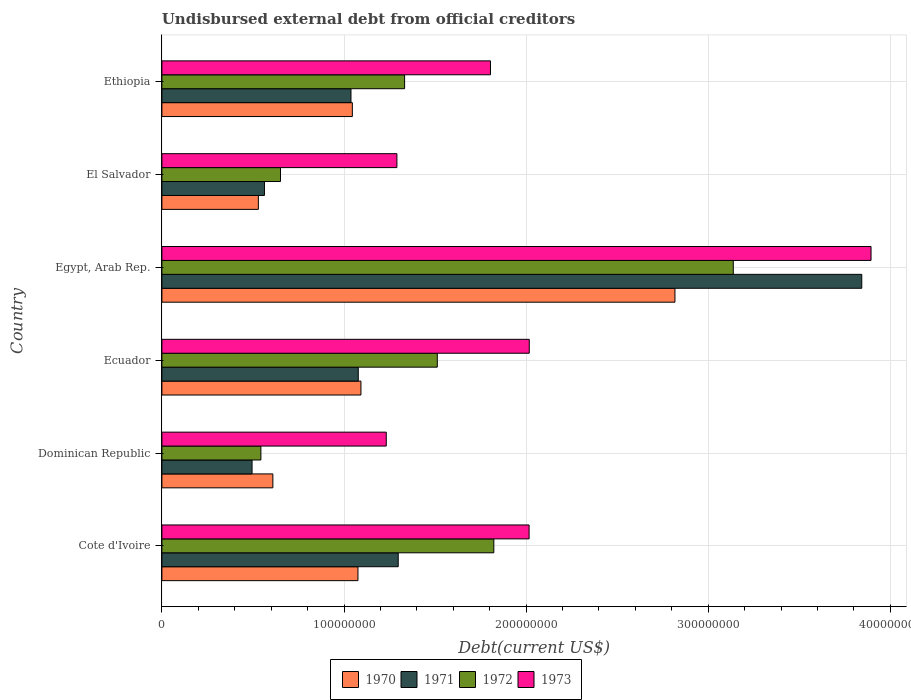How many different coloured bars are there?
Provide a short and direct response. 4. Are the number of bars per tick equal to the number of legend labels?
Keep it short and to the point. Yes. Are the number of bars on each tick of the Y-axis equal?
Give a very brief answer. Yes. How many bars are there on the 4th tick from the top?
Your answer should be very brief. 4. What is the label of the 3rd group of bars from the top?
Make the answer very short. Egypt, Arab Rep. In how many cases, is the number of bars for a given country not equal to the number of legend labels?
Your response must be concise. 0. What is the total debt in 1972 in Egypt, Arab Rep.?
Give a very brief answer. 3.14e+08. Across all countries, what is the maximum total debt in 1972?
Give a very brief answer. 3.14e+08. Across all countries, what is the minimum total debt in 1970?
Offer a very short reply. 5.30e+07. In which country was the total debt in 1971 maximum?
Offer a very short reply. Egypt, Arab Rep. In which country was the total debt in 1970 minimum?
Offer a terse response. El Salvador. What is the total total debt in 1972 in the graph?
Your response must be concise. 9.00e+08. What is the difference between the total debt in 1973 in Egypt, Arab Rep. and that in El Salvador?
Provide a succinct answer. 2.60e+08. What is the difference between the total debt in 1972 in Cote d'Ivoire and the total debt in 1971 in El Salvador?
Provide a succinct answer. 1.26e+08. What is the average total debt in 1971 per country?
Keep it short and to the point. 1.39e+08. What is the difference between the total debt in 1973 and total debt in 1970 in Egypt, Arab Rep.?
Your answer should be compact. 1.08e+08. In how many countries, is the total debt in 1972 greater than 220000000 US$?
Make the answer very short. 1. What is the ratio of the total debt in 1971 in Ecuador to that in Ethiopia?
Offer a very short reply. 1.04. Is the total debt in 1972 in Ecuador less than that in Ethiopia?
Offer a very short reply. No. What is the difference between the highest and the second highest total debt in 1972?
Your answer should be very brief. 1.31e+08. What is the difference between the highest and the lowest total debt in 1972?
Provide a short and direct response. 2.59e+08. Is it the case that in every country, the sum of the total debt in 1970 and total debt in 1973 is greater than the sum of total debt in 1972 and total debt in 1971?
Provide a short and direct response. No. What does the 2nd bar from the top in Ethiopia represents?
Offer a very short reply. 1972. How many bars are there?
Ensure brevity in your answer.  24. What is the difference between two consecutive major ticks on the X-axis?
Offer a terse response. 1.00e+08. Does the graph contain grids?
Give a very brief answer. Yes. How many legend labels are there?
Your response must be concise. 4. What is the title of the graph?
Ensure brevity in your answer.  Undisbursed external debt from official creditors. What is the label or title of the X-axis?
Your answer should be very brief. Debt(current US$). What is the label or title of the Y-axis?
Provide a succinct answer. Country. What is the Debt(current US$) in 1970 in Cote d'Ivoire?
Offer a very short reply. 1.08e+08. What is the Debt(current US$) of 1971 in Cote d'Ivoire?
Ensure brevity in your answer.  1.30e+08. What is the Debt(current US$) of 1972 in Cote d'Ivoire?
Your answer should be compact. 1.82e+08. What is the Debt(current US$) of 1973 in Cote d'Ivoire?
Offer a very short reply. 2.02e+08. What is the Debt(current US$) of 1970 in Dominican Republic?
Your answer should be compact. 6.09e+07. What is the Debt(current US$) of 1971 in Dominican Republic?
Give a very brief answer. 4.95e+07. What is the Debt(current US$) in 1972 in Dominican Republic?
Offer a very short reply. 5.44e+07. What is the Debt(current US$) of 1973 in Dominican Republic?
Offer a terse response. 1.23e+08. What is the Debt(current US$) in 1970 in Ecuador?
Your answer should be compact. 1.09e+08. What is the Debt(current US$) in 1971 in Ecuador?
Provide a short and direct response. 1.08e+08. What is the Debt(current US$) in 1972 in Ecuador?
Offer a very short reply. 1.51e+08. What is the Debt(current US$) in 1973 in Ecuador?
Your answer should be compact. 2.02e+08. What is the Debt(current US$) in 1970 in Egypt, Arab Rep.?
Keep it short and to the point. 2.82e+08. What is the Debt(current US$) in 1971 in Egypt, Arab Rep.?
Your answer should be compact. 3.84e+08. What is the Debt(current US$) of 1972 in Egypt, Arab Rep.?
Offer a terse response. 3.14e+08. What is the Debt(current US$) in 1973 in Egypt, Arab Rep.?
Give a very brief answer. 3.89e+08. What is the Debt(current US$) of 1970 in El Salvador?
Ensure brevity in your answer.  5.30e+07. What is the Debt(current US$) of 1971 in El Salvador?
Provide a short and direct response. 5.63e+07. What is the Debt(current US$) of 1972 in El Salvador?
Give a very brief answer. 6.51e+07. What is the Debt(current US$) in 1973 in El Salvador?
Ensure brevity in your answer.  1.29e+08. What is the Debt(current US$) in 1970 in Ethiopia?
Your answer should be compact. 1.05e+08. What is the Debt(current US$) of 1971 in Ethiopia?
Keep it short and to the point. 1.04e+08. What is the Debt(current US$) of 1972 in Ethiopia?
Your answer should be compact. 1.33e+08. What is the Debt(current US$) in 1973 in Ethiopia?
Provide a short and direct response. 1.80e+08. Across all countries, what is the maximum Debt(current US$) of 1970?
Offer a very short reply. 2.82e+08. Across all countries, what is the maximum Debt(current US$) in 1971?
Offer a very short reply. 3.84e+08. Across all countries, what is the maximum Debt(current US$) of 1972?
Your answer should be very brief. 3.14e+08. Across all countries, what is the maximum Debt(current US$) in 1973?
Your answer should be compact. 3.89e+08. Across all countries, what is the minimum Debt(current US$) in 1970?
Keep it short and to the point. 5.30e+07. Across all countries, what is the minimum Debt(current US$) in 1971?
Offer a very short reply. 4.95e+07. Across all countries, what is the minimum Debt(current US$) in 1972?
Offer a terse response. 5.44e+07. Across all countries, what is the minimum Debt(current US$) of 1973?
Ensure brevity in your answer.  1.23e+08. What is the total Debt(current US$) of 1970 in the graph?
Give a very brief answer. 7.17e+08. What is the total Debt(current US$) in 1971 in the graph?
Make the answer very short. 8.32e+08. What is the total Debt(current US$) of 1972 in the graph?
Make the answer very short. 9.00e+08. What is the total Debt(current US$) of 1973 in the graph?
Offer a terse response. 1.23e+09. What is the difference between the Debt(current US$) in 1970 in Cote d'Ivoire and that in Dominican Republic?
Keep it short and to the point. 4.67e+07. What is the difference between the Debt(current US$) of 1971 in Cote d'Ivoire and that in Dominican Republic?
Provide a short and direct response. 8.03e+07. What is the difference between the Debt(current US$) in 1972 in Cote d'Ivoire and that in Dominican Republic?
Your response must be concise. 1.28e+08. What is the difference between the Debt(current US$) of 1973 in Cote d'Ivoire and that in Dominican Republic?
Your answer should be compact. 7.84e+07. What is the difference between the Debt(current US$) in 1970 in Cote d'Ivoire and that in Ecuador?
Your response must be concise. -1.64e+06. What is the difference between the Debt(current US$) in 1971 in Cote d'Ivoire and that in Ecuador?
Make the answer very short. 2.19e+07. What is the difference between the Debt(current US$) in 1972 in Cote d'Ivoire and that in Ecuador?
Your answer should be compact. 3.10e+07. What is the difference between the Debt(current US$) of 1973 in Cote d'Ivoire and that in Ecuador?
Provide a short and direct response. -8.40e+04. What is the difference between the Debt(current US$) of 1970 in Cote d'Ivoire and that in Egypt, Arab Rep.?
Offer a terse response. -1.74e+08. What is the difference between the Debt(current US$) in 1971 in Cote d'Ivoire and that in Egypt, Arab Rep.?
Offer a very short reply. -2.55e+08. What is the difference between the Debt(current US$) in 1972 in Cote d'Ivoire and that in Egypt, Arab Rep.?
Your answer should be very brief. -1.31e+08. What is the difference between the Debt(current US$) in 1973 in Cote d'Ivoire and that in Egypt, Arab Rep.?
Ensure brevity in your answer.  -1.88e+08. What is the difference between the Debt(current US$) in 1970 in Cote d'Ivoire and that in El Salvador?
Keep it short and to the point. 5.47e+07. What is the difference between the Debt(current US$) of 1971 in Cote d'Ivoire and that in El Salvador?
Offer a very short reply. 7.35e+07. What is the difference between the Debt(current US$) of 1972 in Cote d'Ivoire and that in El Salvador?
Give a very brief answer. 1.17e+08. What is the difference between the Debt(current US$) in 1973 in Cote d'Ivoire and that in El Salvador?
Provide a short and direct response. 7.26e+07. What is the difference between the Debt(current US$) of 1970 in Cote d'Ivoire and that in Ethiopia?
Ensure brevity in your answer.  3.08e+06. What is the difference between the Debt(current US$) in 1971 in Cote d'Ivoire and that in Ethiopia?
Your response must be concise. 2.59e+07. What is the difference between the Debt(current US$) of 1972 in Cote d'Ivoire and that in Ethiopia?
Offer a terse response. 4.90e+07. What is the difference between the Debt(current US$) of 1973 in Cote d'Ivoire and that in Ethiopia?
Keep it short and to the point. 2.12e+07. What is the difference between the Debt(current US$) of 1970 in Dominican Republic and that in Ecuador?
Ensure brevity in your answer.  -4.84e+07. What is the difference between the Debt(current US$) in 1971 in Dominican Republic and that in Ecuador?
Keep it short and to the point. -5.83e+07. What is the difference between the Debt(current US$) in 1972 in Dominican Republic and that in Ecuador?
Your answer should be very brief. -9.69e+07. What is the difference between the Debt(current US$) of 1973 in Dominican Republic and that in Ecuador?
Make the answer very short. -7.85e+07. What is the difference between the Debt(current US$) of 1970 in Dominican Republic and that in Egypt, Arab Rep.?
Provide a short and direct response. -2.21e+08. What is the difference between the Debt(current US$) of 1971 in Dominican Republic and that in Egypt, Arab Rep.?
Offer a very short reply. -3.35e+08. What is the difference between the Debt(current US$) in 1972 in Dominican Republic and that in Egypt, Arab Rep.?
Give a very brief answer. -2.59e+08. What is the difference between the Debt(current US$) in 1973 in Dominican Republic and that in Egypt, Arab Rep.?
Offer a terse response. -2.66e+08. What is the difference between the Debt(current US$) in 1970 in Dominican Republic and that in El Salvador?
Keep it short and to the point. 7.96e+06. What is the difference between the Debt(current US$) of 1971 in Dominican Republic and that in El Salvador?
Offer a terse response. -6.81e+06. What is the difference between the Debt(current US$) of 1972 in Dominican Republic and that in El Salvador?
Ensure brevity in your answer.  -1.08e+07. What is the difference between the Debt(current US$) of 1973 in Dominican Republic and that in El Salvador?
Make the answer very short. -5.85e+06. What is the difference between the Debt(current US$) in 1970 in Dominican Republic and that in Ethiopia?
Your answer should be very brief. -4.36e+07. What is the difference between the Debt(current US$) in 1971 in Dominican Republic and that in Ethiopia?
Give a very brief answer. -5.43e+07. What is the difference between the Debt(current US$) of 1972 in Dominican Republic and that in Ethiopia?
Provide a short and direct response. -7.89e+07. What is the difference between the Debt(current US$) in 1973 in Dominican Republic and that in Ethiopia?
Your answer should be compact. -5.72e+07. What is the difference between the Debt(current US$) in 1970 in Ecuador and that in Egypt, Arab Rep.?
Offer a terse response. -1.72e+08. What is the difference between the Debt(current US$) of 1971 in Ecuador and that in Egypt, Arab Rep.?
Your response must be concise. -2.76e+08. What is the difference between the Debt(current US$) of 1972 in Ecuador and that in Egypt, Arab Rep.?
Make the answer very short. -1.63e+08. What is the difference between the Debt(current US$) of 1973 in Ecuador and that in Egypt, Arab Rep.?
Provide a short and direct response. -1.88e+08. What is the difference between the Debt(current US$) of 1970 in Ecuador and that in El Salvador?
Give a very brief answer. 5.63e+07. What is the difference between the Debt(current US$) in 1971 in Ecuador and that in El Salvador?
Ensure brevity in your answer.  5.15e+07. What is the difference between the Debt(current US$) in 1972 in Ecuador and that in El Salvador?
Provide a succinct answer. 8.61e+07. What is the difference between the Debt(current US$) of 1973 in Ecuador and that in El Salvador?
Offer a very short reply. 7.27e+07. What is the difference between the Debt(current US$) of 1970 in Ecuador and that in Ethiopia?
Give a very brief answer. 4.72e+06. What is the difference between the Debt(current US$) in 1971 in Ecuador and that in Ethiopia?
Your response must be concise. 4.00e+06. What is the difference between the Debt(current US$) in 1972 in Ecuador and that in Ethiopia?
Your response must be concise. 1.80e+07. What is the difference between the Debt(current US$) in 1973 in Ecuador and that in Ethiopia?
Offer a terse response. 2.13e+07. What is the difference between the Debt(current US$) in 1970 in Egypt, Arab Rep. and that in El Salvador?
Keep it short and to the point. 2.29e+08. What is the difference between the Debt(current US$) of 1971 in Egypt, Arab Rep. and that in El Salvador?
Offer a very short reply. 3.28e+08. What is the difference between the Debt(current US$) of 1972 in Egypt, Arab Rep. and that in El Salvador?
Your response must be concise. 2.49e+08. What is the difference between the Debt(current US$) in 1973 in Egypt, Arab Rep. and that in El Salvador?
Your response must be concise. 2.60e+08. What is the difference between the Debt(current US$) of 1970 in Egypt, Arab Rep. and that in Ethiopia?
Provide a short and direct response. 1.77e+08. What is the difference between the Debt(current US$) of 1971 in Egypt, Arab Rep. and that in Ethiopia?
Your response must be concise. 2.80e+08. What is the difference between the Debt(current US$) in 1972 in Egypt, Arab Rep. and that in Ethiopia?
Keep it short and to the point. 1.80e+08. What is the difference between the Debt(current US$) of 1973 in Egypt, Arab Rep. and that in Ethiopia?
Your answer should be very brief. 2.09e+08. What is the difference between the Debt(current US$) of 1970 in El Salvador and that in Ethiopia?
Give a very brief answer. -5.16e+07. What is the difference between the Debt(current US$) in 1971 in El Salvador and that in Ethiopia?
Provide a short and direct response. -4.75e+07. What is the difference between the Debt(current US$) of 1972 in El Salvador and that in Ethiopia?
Your response must be concise. -6.81e+07. What is the difference between the Debt(current US$) of 1973 in El Salvador and that in Ethiopia?
Keep it short and to the point. -5.14e+07. What is the difference between the Debt(current US$) in 1970 in Cote d'Ivoire and the Debt(current US$) in 1971 in Dominican Republic?
Your response must be concise. 5.81e+07. What is the difference between the Debt(current US$) in 1970 in Cote d'Ivoire and the Debt(current US$) in 1972 in Dominican Republic?
Your answer should be very brief. 5.33e+07. What is the difference between the Debt(current US$) of 1970 in Cote d'Ivoire and the Debt(current US$) of 1973 in Dominican Republic?
Offer a terse response. -1.55e+07. What is the difference between the Debt(current US$) of 1971 in Cote d'Ivoire and the Debt(current US$) of 1972 in Dominican Republic?
Your answer should be very brief. 7.54e+07. What is the difference between the Debt(current US$) in 1971 in Cote d'Ivoire and the Debt(current US$) in 1973 in Dominican Republic?
Offer a very short reply. 6.57e+06. What is the difference between the Debt(current US$) in 1972 in Cote d'Ivoire and the Debt(current US$) in 1973 in Dominican Republic?
Provide a short and direct response. 5.91e+07. What is the difference between the Debt(current US$) of 1970 in Cote d'Ivoire and the Debt(current US$) of 1971 in Ecuador?
Provide a short and direct response. -1.73e+05. What is the difference between the Debt(current US$) of 1970 in Cote d'Ivoire and the Debt(current US$) of 1972 in Ecuador?
Make the answer very short. -4.36e+07. What is the difference between the Debt(current US$) of 1970 in Cote d'Ivoire and the Debt(current US$) of 1973 in Ecuador?
Ensure brevity in your answer.  -9.41e+07. What is the difference between the Debt(current US$) of 1971 in Cote d'Ivoire and the Debt(current US$) of 1972 in Ecuador?
Provide a succinct answer. -2.15e+07. What is the difference between the Debt(current US$) in 1971 in Cote d'Ivoire and the Debt(current US$) in 1973 in Ecuador?
Keep it short and to the point. -7.20e+07. What is the difference between the Debt(current US$) in 1972 in Cote d'Ivoire and the Debt(current US$) in 1973 in Ecuador?
Offer a very short reply. -1.95e+07. What is the difference between the Debt(current US$) in 1970 in Cote d'Ivoire and the Debt(current US$) in 1971 in Egypt, Arab Rep.?
Your answer should be very brief. -2.77e+08. What is the difference between the Debt(current US$) of 1970 in Cote d'Ivoire and the Debt(current US$) of 1972 in Egypt, Arab Rep.?
Ensure brevity in your answer.  -2.06e+08. What is the difference between the Debt(current US$) in 1970 in Cote d'Ivoire and the Debt(current US$) in 1973 in Egypt, Arab Rep.?
Offer a terse response. -2.82e+08. What is the difference between the Debt(current US$) in 1971 in Cote d'Ivoire and the Debt(current US$) in 1972 in Egypt, Arab Rep.?
Provide a succinct answer. -1.84e+08. What is the difference between the Debt(current US$) in 1971 in Cote d'Ivoire and the Debt(current US$) in 1973 in Egypt, Arab Rep.?
Offer a very short reply. -2.60e+08. What is the difference between the Debt(current US$) in 1972 in Cote d'Ivoire and the Debt(current US$) in 1973 in Egypt, Arab Rep.?
Provide a short and direct response. -2.07e+08. What is the difference between the Debt(current US$) in 1970 in Cote d'Ivoire and the Debt(current US$) in 1971 in El Salvador?
Your answer should be compact. 5.13e+07. What is the difference between the Debt(current US$) of 1970 in Cote d'Ivoire and the Debt(current US$) of 1972 in El Salvador?
Your response must be concise. 4.25e+07. What is the difference between the Debt(current US$) of 1970 in Cote d'Ivoire and the Debt(current US$) of 1973 in El Salvador?
Your answer should be compact. -2.14e+07. What is the difference between the Debt(current US$) of 1971 in Cote d'Ivoire and the Debt(current US$) of 1972 in El Salvador?
Give a very brief answer. 6.46e+07. What is the difference between the Debt(current US$) of 1971 in Cote d'Ivoire and the Debt(current US$) of 1973 in El Salvador?
Your response must be concise. 7.17e+05. What is the difference between the Debt(current US$) of 1972 in Cote d'Ivoire and the Debt(current US$) of 1973 in El Salvador?
Give a very brief answer. 5.32e+07. What is the difference between the Debt(current US$) in 1970 in Cote d'Ivoire and the Debt(current US$) in 1971 in Ethiopia?
Offer a very short reply. 3.83e+06. What is the difference between the Debt(current US$) of 1970 in Cote d'Ivoire and the Debt(current US$) of 1972 in Ethiopia?
Your response must be concise. -2.56e+07. What is the difference between the Debt(current US$) of 1970 in Cote d'Ivoire and the Debt(current US$) of 1973 in Ethiopia?
Ensure brevity in your answer.  -7.28e+07. What is the difference between the Debt(current US$) of 1971 in Cote d'Ivoire and the Debt(current US$) of 1972 in Ethiopia?
Make the answer very short. -3.50e+06. What is the difference between the Debt(current US$) of 1971 in Cote d'Ivoire and the Debt(current US$) of 1973 in Ethiopia?
Make the answer very short. -5.07e+07. What is the difference between the Debt(current US$) in 1972 in Cote d'Ivoire and the Debt(current US$) in 1973 in Ethiopia?
Make the answer very short. 1.84e+06. What is the difference between the Debt(current US$) in 1970 in Dominican Republic and the Debt(current US$) in 1971 in Ecuador?
Keep it short and to the point. -4.69e+07. What is the difference between the Debt(current US$) in 1970 in Dominican Republic and the Debt(current US$) in 1972 in Ecuador?
Provide a short and direct response. -9.03e+07. What is the difference between the Debt(current US$) in 1970 in Dominican Republic and the Debt(current US$) in 1973 in Ecuador?
Your response must be concise. -1.41e+08. What is the difference between the Debt(current US$) of 1971 in Dominican Republic and the Debt(current US$) of 1972 in Ecuador?
Your answer should be very brief. -1.02e+08. What is the difference between the Debt(current US$) of 1971 in Dominican Republic and the Debt(current US$) of 1973 in Ecuador?
Your answer should be very brief. -1.52e+08. What is the difference between the Debt(current US$) in 1972 in Dominican Republic and the Debt(current US$) in 1973 in Ecuador?
Your answer should be very brief. -1.47e+08. What is the difference between the Debt(current US$) of 1970 in Dominican Republic and the Debt(current US$) of 1971 in Egypt, Arab Rep.?
Your answer should be compact. -3.23e+08. What is the difference between the Debt(current US$) of 1970 in Dominican Republic and the Debt(current US$) of 1972 in Egypt, Arab Rep.?
Keep it short and to the point. -2.53e+08. What is the difference between the Debt(current US$) of 1970 in Dominican Republic and the Debt(current US$) of 1973 in Egypt, Arab Rep.?
Provide a succinct answer. -3.28e+08. What is the difference between the Debt(current US$) in 1971 in Dominican Republic and the Debt(current US$) in 1972 in Egypt, Arab Rep.?
Your answer should be compact. -2.64e+08. What is the difference between the Debt(current US$) in 1971 in Dominican Republic and the Debt(current US$) in 1973 in Egypt, Arab Rep.?
Your answer should be compact. -3.40e+08. What is the difference between the Debt(current US$) of 1972 in Dominican Republic and the Debt(current US$) of 1973 in Egypt, Arab Rep.?
Provide a short and direct response. -3.35e+08. What is the difference between the Debt(current US$) of 1970 in Dominican Republic and the Debt(current US$) of 1971 in El Salvador?
Your response must be concise. 4.62e+06. What is the difference between the Debt(current US$) in 1970 in Dominican Republic and the Debt(current US$) in 1972 in El Salvador?
Your response must be concise. -4.20e+06. What is the difference between the Debt(current US$) of 1970 in Dominican Republic and the Debt(current US$) of 1973 in El Salvador?
Offer a terse response. -6.81e+07. What is the difference between the Debt(current US$) of 1971 in Dominican Republic and the Debt(current US$) of 1972 in El Salvador?
Your answer should be compact. -1.56e+07. What is the difference between the Debt(current US$) of 1971 in Dominican Republic and the Debt(current US$) of 1973 in El Salvador?
Keep it short and to the point. -7.95e+07. What is the difference between the Debt(current US$) in 1972 in Dominican Republic and the Debt(current US$) in 1973 in El Salvador?
Offer a terse response. -7.47e+07. What is the difference between the Debt(current US$) of 1970 in Dominican Republic and the Debt(current US$) of 1971 in Ethiopia?
Offer a terse response. -4.29e+07. What is the difference between the Debt(current US$) of 1970 in Dominican Republic and the Debt(current US$) of 1972 in Ethiopia?
Your answer should be very brief. -7.23e+07. What is the difference between the Debt(current US$) of 1970 in Dominican Republic and the Debt(current US$) of 1973 in Ethiopia?
Make the answer very short. -1.20e+08. What is the difference between the Debt(current US$) in 1971 in Dominican Republic and the Debt(current US$) in 1972 in Ethiopia?
Offer a very short reply. -8.38e+07. What is the difference between the Debt(current US$) in 1971 in Dominican Republic and the Debt(current US$) in 1973 in Ethiopia?
Offer a very short reply. -1.31e+08. What is the difference between the Debt(current US$) of 1972 in Dominican Republic and the Debt(current US$) of 1973 in Ethiopia?
Your answer should be very brief. -1.26e+08. What is the difference between the Debt(current US$) of 1970 in Ecuador and the Debt(current US$) of 1971 in Egypt, Arab Rep.?
Your answer should be compact. -2.75e+08. What is the difference between the Debt(current US$) in 1970 in Ecuador and the Debt(current US$) in 1972 in Egypt, Arab Rep.?
Give a very brief answer. -2.04e+08. What is the difference between the Debt(current US$) of 1970 in Ecuador and the Debt(current US$) of 1973 in Egypt, Arab Rep.?
Give a very brief answer. -2.80e+08. What is the difference between the Debt(current US$) of 1971 in Ecuador and the Debt(current US$) of 1972 in Egypt, Arab Rep.?
Ensure brevity in your answer.  -2.06e+08. What is the difference between the Debt(current US$) in 1971 in Ecuador and the Debt(current US$) in 1973 in Egypt, Arab Rep.?
Ensure brevity in your answer.  -2.82e+08. What is the difference between the Debt(current US$) in 1972 in Ecuador and the Debt(current US$) in 1973 in Egypt, Arab Rep.?
Your answer should be very brief. -2.38e+08. What is the difference between the Debt(current US$) of 1970 in Ecuador and the Debt(current US$) of 1971 in El Salvador?
Offer a very short reply. 5.30e+07. What is the difference between the Debt(current US$) of 1970 in Ecuador and the Debt(current US$) of 1972 in El Salvador?
Ensure brevity in your answer.  4.42e+07. What is the difference between the Debt(current US$) in 1970 in Ecuador and the Debt(current US$) in 1973 in El Salvador?
Keep it short and to the point. -1.98e+07. What is the difference between the Debt(current US$) in 1971 in Ecuador and the Debt(current US$) in 1972 in El Salvador?
Your answer should be compact. 4.27e+07. What is the difference between the Debt(current US$) in 1971 in Ecuador and the Debt(current US$) in 1973 in El Salvador?
Your answer should be compact. -2.12e+07. What is the difference between the Debt(current US$) in 1972 in Ecuador and the Debt(current US$) in 1973 in El Salvador?
Provide a succinct answer. 2.22e+07. What is the difference between the Debt(current US$) in 1970 in Ecuador and the Debt(current US$) in 1971 in Ethiopia?
Your answer should be compact. 5.47e+06. What is the difference between the Debt(current US$) in 1970 in Ecuador and the Debt(current US$) in 1972 in Ethiopia?
Offer a very short reply. -2.40e+07. What is the difference between the Debt(current US$) of 1970 in Ecuador and the Debt(current US$) of 1973 in Ethiopia?
Ensure brevity in your answer.  -7.11e+07. What is the difference between the Debt(current US$) in 1971 in Ecuador and the Debt(current US$) in 1972 in Ethiopia?
Make the answer very short. -2.54e+07. What is the difference between the Debt(current US$) in 1971 in Ecuador and the Debt(current US$) in 1973 in Ethiopia?
Your answer should be compact. -7.26e+07. What is the difference between the Debt(current US$) in 1972 in Ecuador and the Debt(current US$) in 1973 in Ethiopia?
Offer a very short reply. -2.92e+07. What is the difference between the Debt(current US$) of 1970 in Egypt, Arab Rep. and the Debt(current US$) of 1971 in El Salvador?
Provide a succinct answer. 2.25e+08. What is the difference between the Debt(current US$) of 1970 in Egypt, Arab Rep. and the Debt(current US$) of 1972 in El Salvador?
Offer a very short reply. 2.17e+08. What is the difference between the Debt(current US$) in 1970 in Egypt, Arab Rep. and the Debt(current US$) in 1973 in El Salvador?
Give a very brief answer. 1.53e+08. What is the difference between the Debt(current US$) of 1971 in Egypt, Arab Rep. and the Debt(current US$) of 1972 in El Salvador?
Offer a terse response. 3.19e+08. What is the difference between the Debt(current US$) in 1971 in Egypt, Arab Rep. and the Debt(current US$) in 1973 in El Salvador?
Your answer should be compact. 2.55e+08. What is the difference between the Debt(current US$) of 1972 in Egypt, Arab Rep. and the Debt(current US$) of 1973 in El Salvador?
Your answer should be very brief. 1.85e+08. What is the difference between the Debt(current US$) of 1970 in Egypt, Arab Rep. and the Debt(current US$) of 1971 in Ethiopia?
Offer a very short reply. 1.78e+08. What is the difference between the Debt(current US$) of 1970 in Egypt, Arab Rep. and the Debt(current US$) of 1972 in Ethiopia?
Your response must be concise. 1.48e+08. What is the difference between the Debt(current US$) of 1970 in Egypt, Arab Rep. and the Debt(current US$) of 1973 in Ethiopia?
Offer a very short reply. 1.01e+08. What is the difference between the Debt(current US$) of 1971 in Egypt, Arab Rep. and the Debt(current US$) of 1972 in Ethiopia?
Your response must be concise. 2.51e+08. What is the difference between the Debt(current US$) of 1971 in Egypt, Arab Rep. and the Debt(current US$) of 1973 in Ethiopia?
Offer a very short reply. 2.04e+08. What is the difference between the Debt(current US$) of 1972 in Egypt, Arab Rep. and the Debt(current US$) of 1973 in Ethiopia?
Your answer should be compact. 1.33e+08. What is the difference between the Debt(current US$) in 1970 in El Salvador and the Debt(current US$) in 1971 in Ethiopia?
Provide a succinct answer. -5.09e+07. What is the difference between the Debt(current US$) of 1970 in El Salvador and the Debt(current US$) of 1972 in Ethiopia?
Your answer should be very brief. -8.03e+07. What is the difference between the Debt(current US$) of 1970 in El Salvador and the Debt(current US$) of 1973 in Ethiopia?
Give a very brief answer. -1.27e+08. What is the difference between the Debt(current US$) in 1971 in El Salvador and the Debt(current US$) in 1972 in Ethiopia?
Provide a succinct answer. -7.70e+07. What is the difference between the Debt(current US$) of 1971 in El Salvador and the Debt(current US$) of 1973 in Ethiopia?
Make the answer very short. -1.24e+08. What is the difference between the Debt(current US$) in 1972 in El Salvador and the Debt(current US$) in 1973 in Ethiopia?
Offer a very short reply. -1.15e+08. What is the average Debt(current US$) of 1970 per country?
Make the answer very short. 1.20e+08. What is the average Debt(current US$) in 1971 per country?
Your answer should be compact. 1.39e+08. What is the average Debt(current US$) of 1972 per country?
Ensure brevity in your answer.  1.50e+08. What is the average Debt(current US$) in 1973 per country?
Offer a very short reply. 2.04e+08. What is the difference between the Debt(current US$) in 1970 and Debt(current US$) in 1971 in Cote d'Ivoire?
Your answer should be very brief. -2.21e+07. What is the difference between the Debt(current US$) in 1970 and Debt(current US$) in 1972 in Cote d'Ivoire?
Give a very brief answer. -7.46e+07. What is the difference between the Debt(current US$) in 1970 and Debt(current US$) in 1973 in Cote d'Ivoire?
Your answer should be very brief. -9.40e+07. What is the difference between the Debt(current US$) in 1971 and Debt(current US$) in 1972 in Cote d'Ivoire?
Your response must be concise. -5.25e+07. What is the difference between the Debt(current US$) of 1971 and Debt(current US$) of 1973 in Cote d'Ivoire?
Make the answer very short. -7.19e+07. What is the difference between the Debt(current US$) in 1972 and Debt(current US$) in 1973 in Cote d'Ivoire?
Your response must be concise. -1.94e+07. What is the difference between the Debt(current US$) of 1970 and Debt(current US$) of 1971 in Dominican Republic?
Ensure brevity in your answer.  1.14e+07. What is the difference between the Debt(current US$) of 1970 and Debt(current US$) of 1972 in Dominican Republic?
Give a very brief answer. 6.57e+06. What is the difference between the Debt(current US$) in 1970 and Debt(current US$) in 1973 in Dominican Republic?
Give a very brief answer. -6.23e+07. What is the difference between the Debt(current US$) in 1971 and Debt(current US$) in 1972 in Dominican Republic?
Offer a terse response. -4.85e+06. What is the difference between the Debt(current US$) of 1971 and Debt(current US$) of 1973 in Dominican Republic?
Your response must be concise. -7.37e+07. What is the difference between the Debt(current US$) in 1972 and Debt(current US$) in 1973 in Dominican Republic?
Provide a short and direct response. -6.88e+07. What is the difference between the Debt(current US$) in 1970 and Debt(current US$) in 1971 in Ecuador?
Offer a very short reply. 1.47e+06. What is the difference between the Debt(current US$) in 1970 and Debt(current US$) in 1972 in Ecuador?
Ensure brevity in your answer.  -4.19e+07. What is the difference between the Debt(current US$) in 1970 and Debt(current US$) in 1973 in Ecuador?
Your answer should be very brief. -9.24e+07. What is the difference between the Debt(current US$) of 1971 and Debt(current US$) of 1972 in Ecuador?
Provide a short and direct response. -4.34e+07. What is the difference between the Debt(current US$) of 1971 and Debt(current US$) of 1973 in Ecuador?
Offer a very short reply. -9.39e+07. What is the difference between the Debt(current US$) of 1972 and Debt(current US$) of 1973 in Ecuador?
Your response must be concise. -5.05e+07. What is the difference between the Debt(current US$) in 1970 and Debt(current US$) in 1971 in Egypt, Arab Rep.?
Your answer should be compact. -1.03e+08. What is the difference between the Debt(current US$) of 1970 and Debt(current US$) of 1972 in Egypt, Arab Rep.?
Keep it short and to the point. -3.20e+07. What is the difference between the Debt(current US$) in 1970 and Debt(current US$) in 1973 in Egypt, Arab Rep.?
Your response must be concise. -1.08e+08. What is the difference between the Debt(current US$) in 1971 and Debt(current US$) in 1972 in Egypt, Arab Rep.?
Your answer should be very brief. 7.06e+07. What is the difference between the Debt(current US$) of 1971 and Debt(current US$) of 1973 in Egypt, Arab Rep.?
Provide a short and direct response. -5.09e+06. What is the difference between the Debt(current US$) in 1972 and Debt(current US$) in 1973 in Egypt, Arab Rep.?
Your answer should be very brief. -7.56e+07. What is the difference between the Debt(current US$) of 1970 and Debt(current US$) of 1971 in El Salvador?
Offer a terse response. -3.35e+06. What is the difference between the Debt(current US$) in 1970 and Debt(current US$) in 1972 in El Salvador?
Provide a succinct answer. -1.22e+07. What is the difference between the Debt(current US$) in 1970 and Debt(current US$) in 1973 in El Salvador?
Your answer should be compact. -7.61e+07. What is the difference between the Debt(current US$) in 1971 and Debt(current US$) in 1972 in El Salvador?
Offer a terse response. -8.81e+06. What is the difference between the Debt(current US$) in 1971 and Debt(current US$) in 1973 in El Salvador?
Your answer should be compact. -7.27e+07. What is the difference between the Debt(current US$) in 1972 and Debt(current US$) in 1973 in El Salvador?
Provide a succinct answer. -6.39e+07. What is the difference between the Debt(current US$) of 1970 and Debt(current US$) of 1971 in Ethiopia?
Your answer should be compact. 7.54e+05. What is the difference between the Debt(current US$) of 1970 and Debt(current US$) of 1972 in Ethiopia?
Your answer should be compact. -2.87e+07. What is the difference between the Debt(current US$) of 1970 and Debt(current US$) of 1973 in Ethiopia?
Keep it short and to the point. -7.59e+07. What is the difference between the Debt(current US$) of 1971 and Debt(current US$) of 1972 in Ethiopia?
Your response must be concise. -2.94e+07. What is the difference between the Debt(current US$) in 1971 and Debt(current US$) in 1973 in Ethiopia?
Your answer should be compact. -7.66e+07. What is the difference between the Debt(current US$) of 1972 and Debt(current US$) of 1973 in Ethiopia?
Ensure brevity in your answer.  -4.72e+07. What is the ratio of the Debt(current US$) in 1970 in Cote d'Ivoire to that in Dominican Republic?
Provide a short and direct response. 1.77. What is the ratio of the Debt(current US$) of 1971 in Cote d'Ivoire to that in Dominican Republic?
Your answer should be compact. 2.62. What is the ratio of the Debt(current US$) of 1972 in Cote d'Ivoire to that in Dominican Republic?
Make the answer very short. 3.35. What is the ratio of the Debt(current US$) of 1973 in Cote d'Ivoire to that in Dominican Republic?
Give a very brief answer. 1.64. What is the ratio of the Debt(current US$) of 1971 in Cote d'Ivoire to that in Ecuador?
Offer a very short reply. 1.2. What is the ratio of the Debt(current US$) of 1972 in Cote d'Ivoire to that in Ecuador?
Ensure brevity in your answer.  1.21. What is the ratio of the Debt(current US$) in 1970 in Cote d'Ivoire to that in Egypt, Arab Rep.?
Provide a succinct answer. 0.38. What is the ratio of the Debt(current US$) of 1971 in Cote d'Ivoire to that in Egypt, Arab Rep.?
Offer a very short reply. 0.34. What is the ratio of the Debt(current US$) in 1972 in Cote d'Ivoire to that in Egypt, Arab Rep.?
Offer a terse response. 0.58. What is the ratio of the Debt(current US$) in 1973 in Cote d'Ivoire to that in Egypt, Arab Rep.?
Make the answer very short. 0.52. What is the ratio of the Debt(current US$) in 1970 in Cote d'Ivoire to that in El Salvador?
Offer a terse response. 2.03. What is the ratio of the Debt(current US$) of 1971 in Cote d'Ivoire to that in El Salvador?
Your answer should be compact. 2.3. What is the ratio of the Debt(current US$) in 1972 in Cote d'Ivoire to that in El Salvador?
Provide a succinct answer. 2.8. What is the ratio of the Debt(current US$) of 1973 in Cote d'Ivoire to that in El Salvador?
Ensure brevity in your answer.  1.56. What is the ratio of the Debt(current US$) of 1970 in Cote d'Ivoire to that in Ethiopia?
Make the answer very short. 1.03. What is the ratio of the Debt(current US$) of 1971 in Cote d'Ivoire to that in Ethiopia?
Make the answer very short. 1.25. What is the ratio of the Debt(current US$) of 1972 in Cote d'Ivoire to that in Ethiopia?
Make the answer very short. 1.37. What is the ratio of the Debt(current US$) of 1973 in Cote d'Ivoire to that in Ethiopia?
Your answer should be very brief. 1.12. What is the ratio of the Debt(current US$) of 1970 in Dominican Republic to that in Ecuador?
Offer a very short reply. 0.56. What is the ratio of the Debt(current US$) in 1971 in Dominican Republic to that in Ecuador?
Offer a very short reply. 0.46. What is the ratio of the Debt(current US$) of 1972 in Dominican Republic to that in Ecuador?
Your answer should be very brief. 0.36. What is the ratio of the Debt(current US$) of 1973 in Dominican Republic to that in Ecuador?
Give a very brief answer. 0.61. What is the ratio of the Debt(current US$) of 1970 in Dominican Republic to that in Egypt, Arab Rep.?
Keep it short and to the point. 0.22. What is the ratio of the Debt(current US$) of 1971 in Dominican Republic to that in Egypt, Arab Rep.?
Offer a very short reply. 0.13. What is the ratio of the Debt(current US$) of 1972 in Dominican Republic to that in Egypt, Arab Rep.?
Your response must be concise. 0.17. What is the ratio of the Debt(current US$) in 1973 in Dominican Republic to that in Egypt, Arab Rep.?
Offer a very short reply. 0.32. What is the ratio of the Debt(current US$) of 1970 in Dominican Republic to that in El Salvador?
Offer a terse response. 1.15. What is the ratio of the Debt(current US$) in 1971 in Dominican Republic to that in El Salvador?
Provide a succinct answer. 0.88. What is the ratio of the Debt(current US$) in 1972 in Dominican Republic to that in El Salvador?
Your answer should be very brief. 0.83. What is the ratio of the Debt(current US$) in 1973 in Dominican Republic to that in El Salvador?
Your response must be concise. 0.95. What is the ratio of the Debt(current US$) in 1970 in Dominican Republic to that in Ethiopia?
Your answer should be compact. 0.58. What is the ratio of the Debt(current US$) in 1971 in Dominican Republic to that in Ethiopia?
Give a very brief answer. 0.48. What is the ratio of the Debt(current US$) in 1972 in Dominican Republic to that in Ethiopia?
Offer a very short reply. 0.41. What is the ratio of the Debt(current US$) in 1973 in Dominican Republic to that in Ethiopia?
Make the answer very short. 0.68. What is the ratio of the Debt(current US$) in 1970 in Ecuador to that in Egypt, Arab Rep.?
Provide a succinct answer. 0.39. What is the ratio of the Debt(current US$) in 1971 in Ecuador to that in Egypt, Arab Rep.?
Give a very brief answer. 0.28. What is the ratio of the Debt(current US$) in 1972 in Ecuador to that in Egypt, Arab Rep.?
Ensure brevity in your answer.  0.48. What is the ratio of the Debt(current US$) of 1973 in Ecuador to that in Egypt, Arab Rep.?
Keep it short and to the point. 0.52. What is the ratio of the Debt(current US$) of 1970 in Ecuador to that in El Salvador?
Provide a short and direct response. 2.06. What is the ratio of the Debt(current US$) in 1971 in Ecuador to that in El Salvador?
Your response must be concise. 1.91. What is the ratio of the Debt(current US$) in 1972 in Ecuador to that in El Salvador?
Keep it short and to the point. 2.32. What is the ratio of the Debt(current US$) of 1973 in Ecuador to that in El Salvador?
Your answer should be very brief. 1.56. What is the ratio of the Debt(current US$) in 1970 in Ecuador to that in Ethiopia?
Provide a short and direct response. 1.05. What is the ratio of the Debt(current US$) in 1971 in Ecuador to that in Ethiopia?
Keep it short and to the point. 1.04. What is the ratio of the Debt(current US$) in 1972 in Ecuador to that in Ethiopia?
Keep it short and to the point. 1.13. What is the ratio of the Debt(current US$) in 1973 in Ecuador to that in Ethiopia?
Keep it short and to the point. 1.12. What is the ratio of the Debt(current US$) of 1970 in Egypt, Arab Rep. to that in El Salvador?
Provide a short and direct response. 5.32. What is the ratio of the Debt(current US$) of 1971 in Egypt, Arab Rep. to that in El Salvador?
Ensure brevity in your answer.  6.82. What is the ratio of the Debt(current US$) in 1972 in Egypt, Arab Rep. to that in El Salvador?
Keep it short and to the point. 4.82. What is the ratio of the Debt(current US$) in 1973 in Egypt, Arab Rep. to that in El Salvador?
Your answer should be compact. 3.02. What is the ratio of the Debt(current US$) of 1970 in Egypt, Arab Rep. to that in Ethiopia?
Provide a succinct answer. 2.69. What is the ratio of the Debt(current US$) in 1971 in Egypt, Arab Rep. to that in Ethiopia?
Give a very brief answer. 3.7. What is the ratio of the Debt(current US$) of 1972 in Egypt, Arab Rep. to that in Ethiopia?
Give a very brief answer. 2.35. What is the ratio of the Debt(current US$) of 1973 in Egypt, Arab Rep. to that in Ethiopia?
Ensure brevity in your answer.  2.16. What is the ratio of the Debt(current US$) of 1970 in El Salvador to that in Ethiopia?
Make the answer very short. 0.51. What is the ratio of the Debt(current US$) in 1971 in El Salvador to that in Ethiopia?
Provide a succinct answer. 0.54. What is the ratio of the Debt(current US$) in 1972 in El Salvador to that in Ethiopia?
Give a very brief answer. 0.49. What is the ratio of the Debt(current US$) in 1973 in El Salvador to that in Ethiopia?
Make the answer very short. 0.72. What is the difference between the highest and the second highest Debt(current US$) in 1970?
Offer a very short reply. 1.72e+08. What is the difference between the highest and the second highest Debt(current US$) in 1971?
Your answer should be compact. 2.55e+08. What is the difference between the highest and the second highest Debt(current US$) of 1972?
Make the answer very short. 1.31e+08. What is the difference between the highest and the second highest Debt(current US$) in 1973?
Keep it short and to the point. 1.88e+08. What is the difference between the highest and the lowest Debt(current US$) in 1970?
Offer a terse response. 2.29e+08. What is the difference between the highest and the lowest Debt(current US$) in 1971?
Make the answer very short. 3.35e+08. What is the difference between the highest and the lowest Debt(current US$) of 1972?
Provide a succinct answer. 2.59e+08. What is the difference between the highest and the lowest Debt(current US$) of 1973?
Make the answer very short. 2.66e+08. 